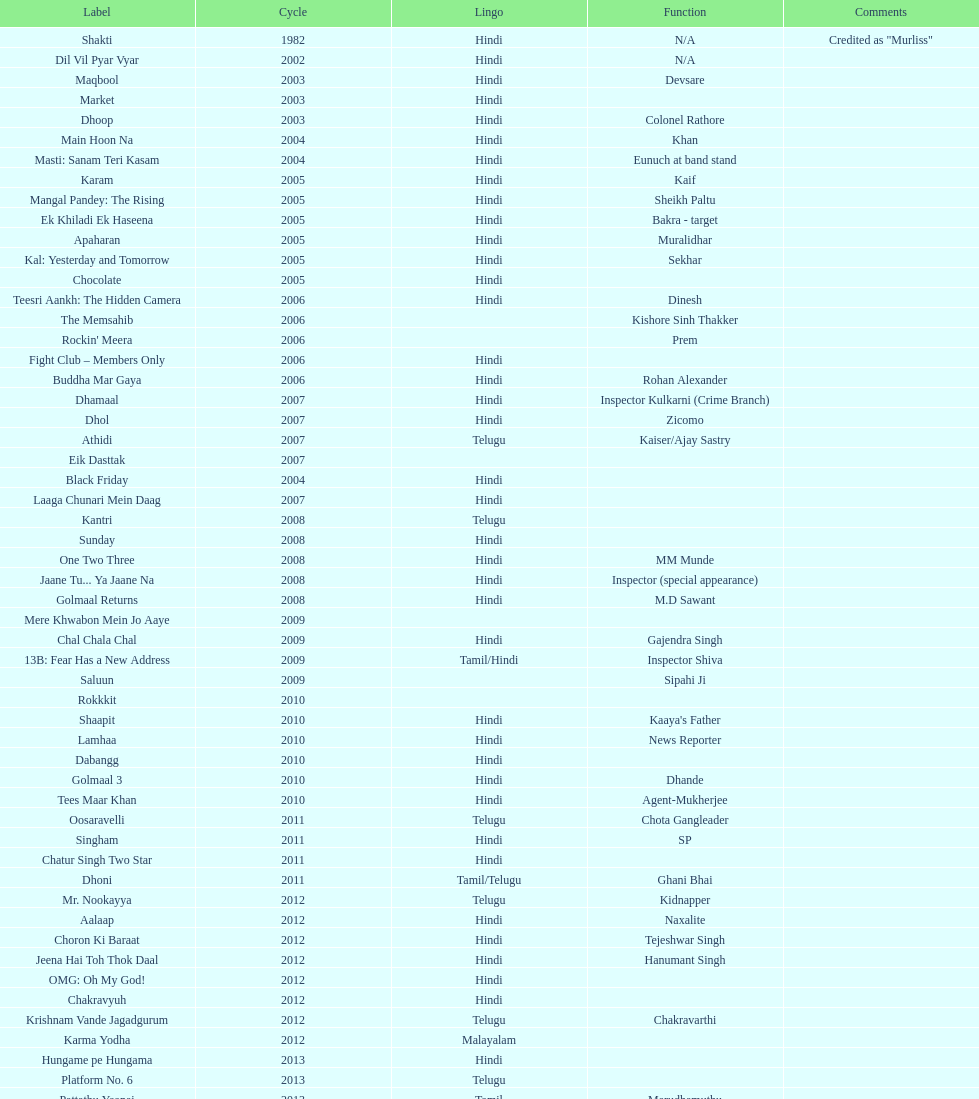What are the number of titles listed in 2005? 6. 